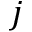Convert formula to latex. <formula><loc_0><loc_0><loc_500><loc_500>j</formula> 